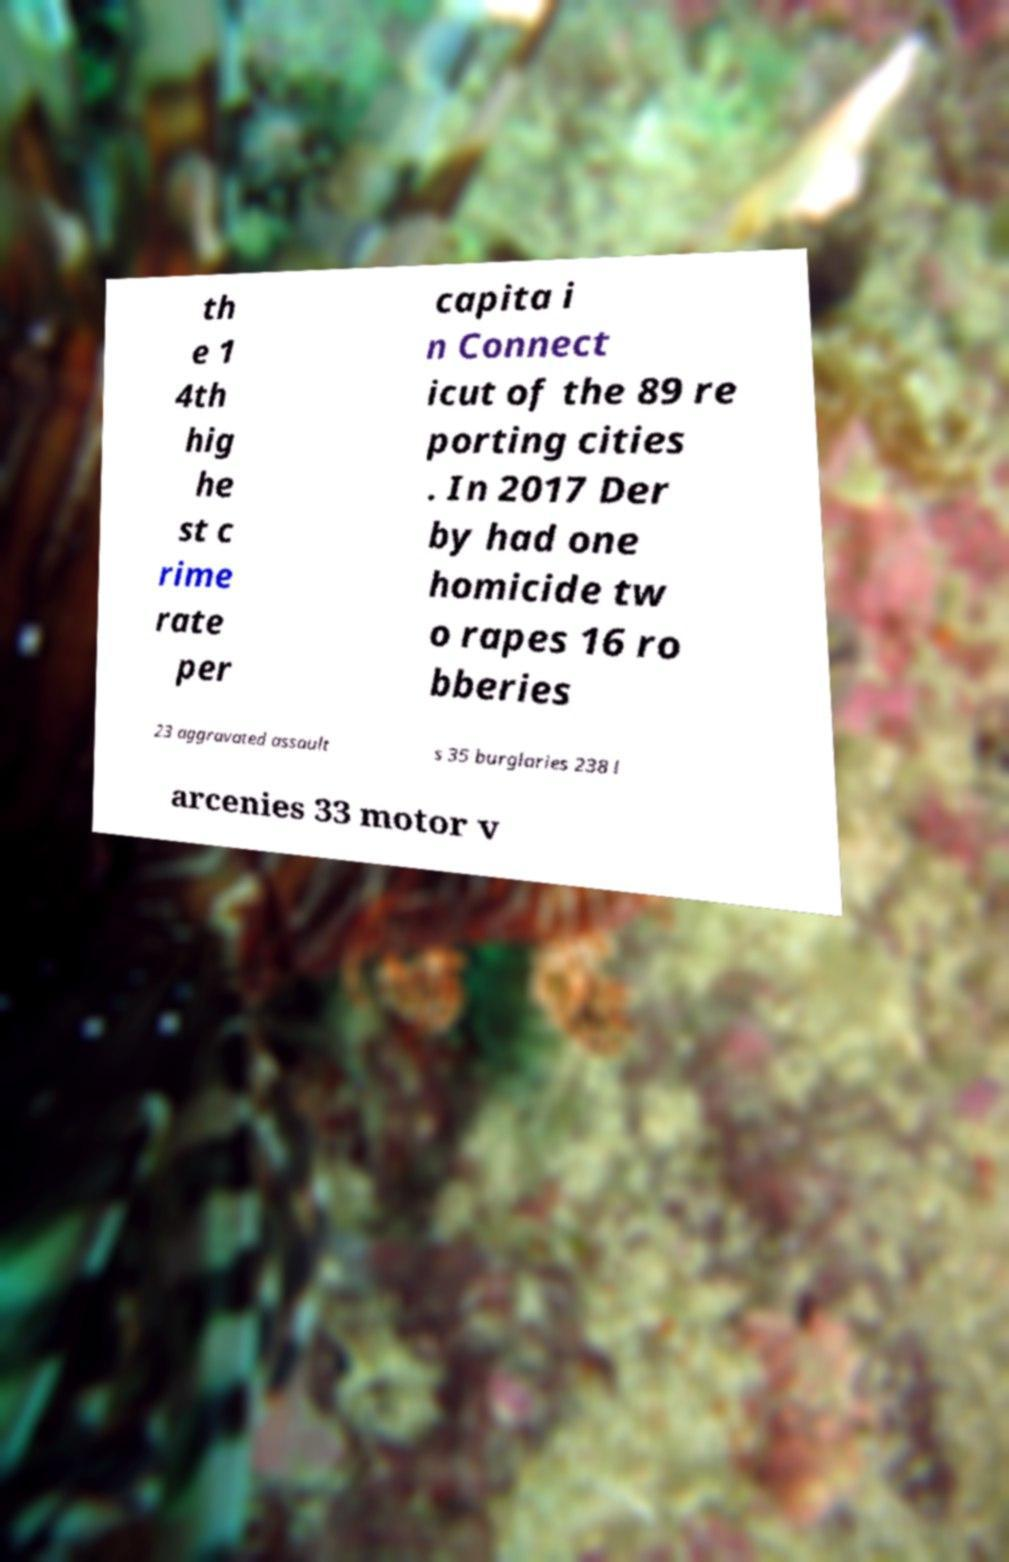What messages or text are displayed in this image? I need them in a readable, typed format. th e 1 4th hig he st c rime rate per capita i n Connect icut of the 89 re porting cities . In 2017 Der by had one homicide tw o rapes 16 ro bberies 23 aggravated assault s 35 burglaries 238 l arcenies 33 motor v 